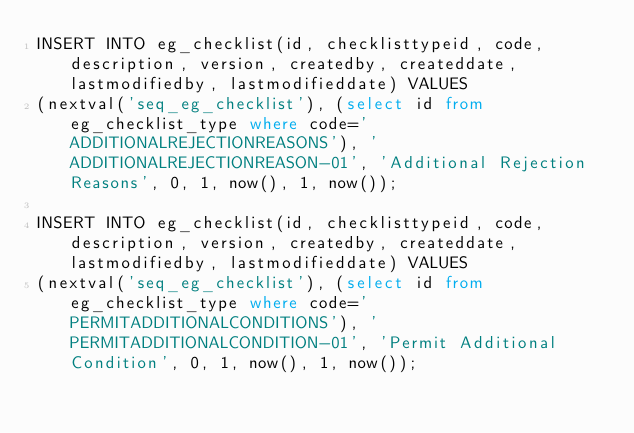<code> <loc_0><loc_0><loc_500><loc_500><_SQL_>INSERT INTO eg_checklist(id, checklisttypeid, code, description, version, createdby, createddate, lastmodifiedby, lastmodifieddate) VALUES 
(nextval('seq_eg_checklist'), (select id from eg_checklist_type where code='ADDITIONALREJECTIONREASONS'), 'ADDITIONALREJECTIONREASON-01', 'Additional Rejection Reasons', 0, 1, now(), 1, now());

INSERT INTO eg_checklist(id, checklisttypeid, code, description, version, createdby, createddate, lastmodifiedby, lastmodifieddate) VALUES 
(nextval('seq_eg_checklist'), (select id from eg_checklist_type where code='PERMITADDITIONALCONDITIONS'), 'PERMITADDITIONALCONDITION-01', 'Permit Additional Condition', 0, 1, now(), 1, now());</code> 